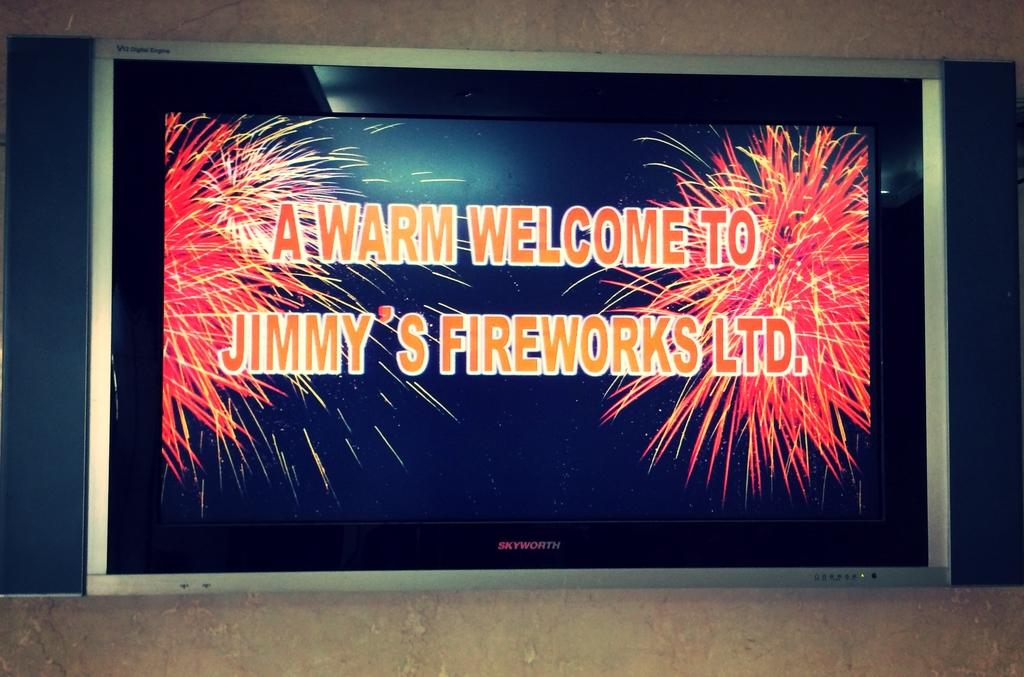<image>
Render a clear and concise summary of the photo. A welcome message for Jimmy's fireworks ltd. is shown on the display. 